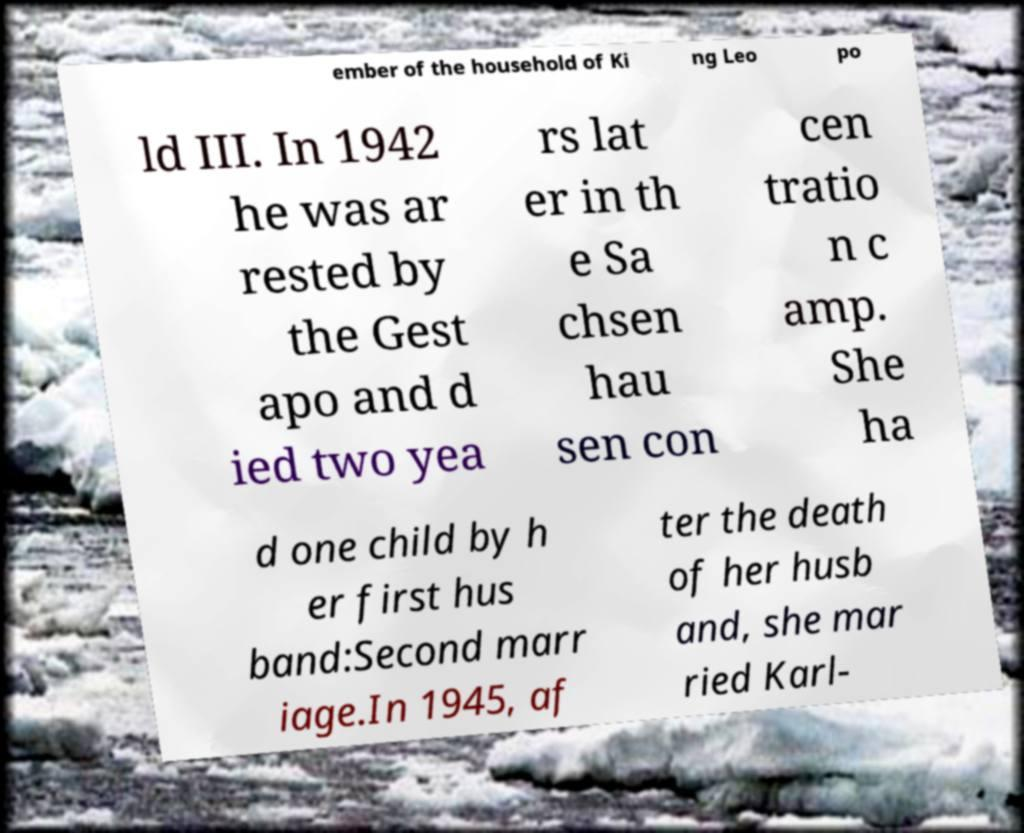I need the written content from this picture converted into text. Can you do that? ember of the household of Ki ng Leo po ld III. In 1942 he was ar rested by the Gest apo and d ied two yea rs lat er in th e Sa chsen hau sen con cen tratio n c amp. She ha d one child by h er first hus band:Second marr iage.In 1945, af ter the death of her husb and, she mar ried Karl- 